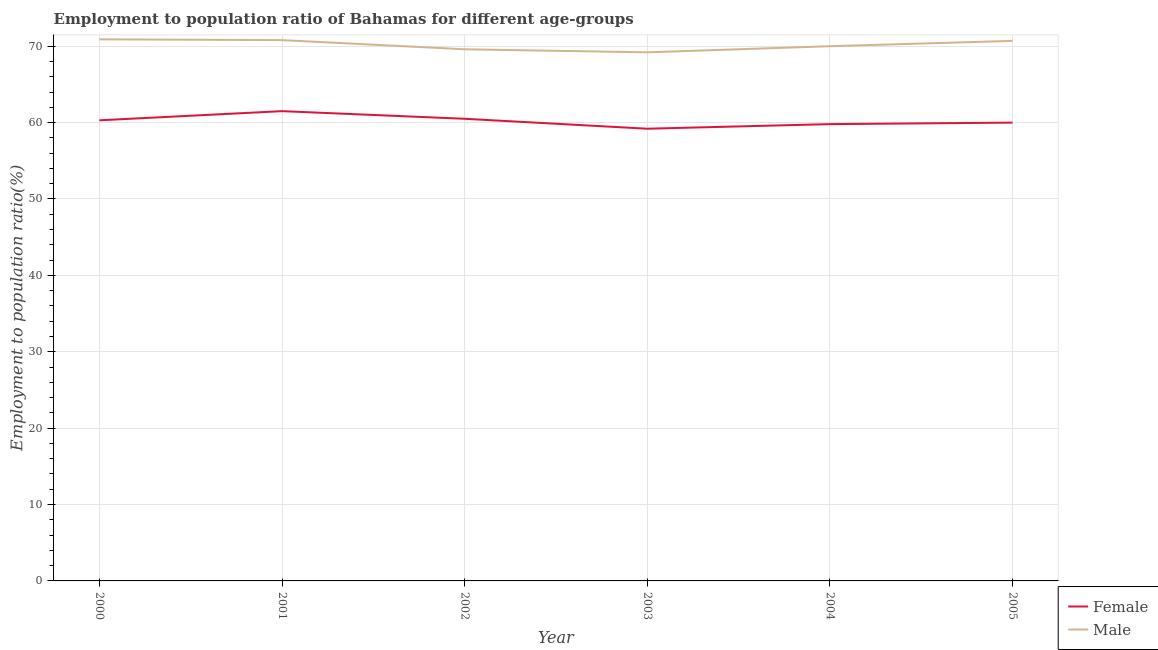How many different coloured lines are there?
Provide a short and direct response. 2. Does the line corresponding to employment to population ratio(female) intersect with the line corresponding to employment to population ratio(male)?
Offer a very short reply. No. Is the number of lines equal to the number of legend labels?
Your answer should be very brief. Yes. What is the employment to population ratio(male) in 2003?
Offer a very short reply. 69.2. Across all years, what is the maximum employment to population ratio(female)?
Give a very brief answer. 61.5. Across all years, what is the minimum employment to population ratio(female)?
Your answer should be very brief. 59.2. In which year was the employment to population ratio(female) minimum?
Your response must be concise. 2003. What is the total employment to population ratio(male) in the graph?
Ensure brevity in your answer.  421.2. What is the difference between the employment to population ratio(male) in 2000 and that in 2005?
Ensure brevity in your answer.  0.2. What is the difference between the employment to population ratio(female) in 2005 and the employment to population ratio(male) in 2002?
Provide a short and direct response. -9.6. What is the average employment to population ratio(male) per year?
Your answer should be very brief. 70.2. In the year 2002, what is the difference between the employment to population ratio(female) and employment to population ratio(male)?
Ensure brevity in your answer.  -9.1. What is the ratio of the employment to population ratio(male) in 2000 to that in 2005?
Provide a short and direct response. 1. Is the employment to population ratio(male) in 2001 less than that in 2004?
Your answer should be very brief. No. What is the difference between the highest and the second highest employment to population ratio(female)?
Your answer should be very brief. 1. What is the difference between the highest and the lowest employment to population ratio(female)?
Offer a very short reply. 2.3. Is the sum of the employment to population ratio(female) in 2003 and 2005 greater than the maximum employment to population ratio(male) across all years?
Offer a terse response. Yes. Is the employment to population ratio(male) strictly less than the employment to population ratio(female) over the years?
Offer a very short reply. No. How many lines are there?
Your response must be concise. 2. How many years are there in the graph?
Offer a very short reply. 6. What is the difference between two consecutive major ticks on the Y-axis?
Your answer should be compact. 10. Are the values on the major ticks of Y-axis written in scientific E-notation?
Provide a succinct answer. No. Where does the legend appear in the graph?
Keep it short and to the point. Bottom right. How many legend labels are there?
Your answer should be very brief. 2. What is the title of the graph?
Provide a short and direct response. Employment to population ratio of Bahamas for different age-groups. What is the label or title of the Y-axis?
Ensure brevity in your answer.  Employment to population ratio(%). What is the Employment to population ratio(%) of Female in 2000?
Keep it short and to the point. 60.3. What is the Employment to population ratio(%) of Male in 2000?
Provide a succinct answer. 70.9. What is the Employment to population ratio(%) in Female in 2001?
Ensure brevity in your answer.  61.5. What is the Employment to population ratio(%) in Male in 2001?
Your answer should be very brief. 70.8. What is the Employment to population ratio(%) in Female in 2002?
Provide a succinct answer. 60.5. What is the Employment to population ratio(%) in Male in 2002?
Offer a very short reply. 69.6. What is the Employment to population ratio(%) of Female in 2003?
Offer a very short reply. 59.2. What is the Employment to population ratio(%) in Male in 2003?
Your answer should be very brief. 69.2. What is the Employment to population ratio(%) in Female in 2004?
Keep it short and to the point. 59.8. What is the Employment to population ratio(%) of Male in 2004?
Your answer should be compact. 70. What is the Employment to population ratio(%) in Female in 2005?
Make the answer very short. 60. What is the Employment to population ratio(%) in Male in 2005?
Your answer should be compact. 70.7. Across all years, what is the maximum Employment to population ratio(%) in Female?
Offer a terse response. 61.5. Across all years, what is the maximum Employment to population ratio(%) in Male?
Your response must be concise. 70.9. Across all years, what is the minimum Employment to population ratio(%) in Female?
Make the answer very short. 59.2. Across all years, what is the minimum Employment to population ratio(%) of Male?
Your response must be concise. 69.2. What is the total Employment to population ratio(%) in Female in the graph?
Give a very brief answer. 361.3. What is the total Employment to population ratio(%) of Male in the graph?
Ensure brevity in your answer.  421.2. What is the difference between the Employment to population ratio(%) in Female in 2000 and that in 2001?
Provide a short and direct response. -1.2. What is the difference between the Employment to population ratio(%) in Female in 2000 and that in 2003?
Keep it short and to the point. 1.1. What is the difference between the Employment to population ratio(%) in Female in 2000 and that in 2004?
Provide a short and direct response. 0.5. What is the difference between the Employment to population ratio(%) in Female in 2000 and that in 2005?
Offer a terse response. 0.3. What is the difference between the Employment to population ratio(%) in Female in 2001 and that in 2005?
Offer a terse response. 1.5. What is the difference between the Employment to population ratio(%) in Male in 2002 and that in 2003?
Give a very brief answer. 0.4. What is the difference between the Employment to population ratio(%) in Female in 2002 and that in 2005?
Keep it short and to the point. 0.5. What is the difference between the Employment to population ratio(%) of Male in 2002 and that in 2005?
Give a very brief answer. -1.1. What is the difference between the Employment to population ratio(%) of Female in 2003 and that in 2004?
Your response must be concise. -0.6. What is the difference between the Employment to population ratio(%) in Female in 2003 and that in 2005?
Make the answer very short. -0.8. What is the difference between the Employment to population ratio(%) in Female in 2000 and the Employment to population ratio(%) in Male in 2002?
Ensure brevity in your answer.  -9.3. What is the difference between the Employment to population ratio(%) in Female in 2000 and the Employment to population ratio(%) in Male in 2003?
Provide a short and direct response. -8.9. What is the difference between the Employment to population ratio(%) of Female in 2001 and the Employment to population ratio(%) of Male in 2002?
Provide a succinct answer. -8.1. What is the difference between the Employment to population ratio(%) of Female in 2001 and the Employment to population ratio(%) of Male in 2004?
Offer a very short reply. -8.5. What is the difference between the Employment to population ratio(%) in Female in 2002 and the Employment to population ratio(%) in Male in 2003?
Provide a short and direct response. -8.7. What is the difference between the Employment to population ratio(%) of Female in 2003 and the Employment to population ratio(%) of Male in 2004?
Offer a terse response. -10.8. What is the average Employment to population ratio(%) of Female per year?
Give a very brief answer. 60.22. What is the average Employment to population ratio(%) in Male per year?
Provide a short and direct response. 70.2. In the year 2001, what is the difference between the Employment to population ratio(%) of Female and Employment to population ratio(%) of Male?
Offer a terse response. -9.3. In the year 2002, what is the difference between the Employment to population ratio(%) in Female and Employment to population ratio(%) in Male?
Provide a succinct answer. -9.1. In the year 2003, what is the difference between the Employment to population ratio(%) of Female and Employment to population ratio(%) of Male?
Your response must be concise. -10. In the year 2004, what is the difference between the Employment to population ratio(%) in Female and Employment to population ratio(%) in Male?
Your answer should be very brief. -10.2. In the year 2005, what is the difference between the Employment to population ratio(%) in Female and Employment to population ratio(%) in Male?
Your answer should be very brief. -10.7. What is the ratio of the Employment to population ratio(%) in Female in 2000 to that in 2001?
Provide a succinct answer. 0.98. What is the ratio of the Employment to population ratio(%) of Male in 2000 to that in 2001?
Ensure brevity in your answer.  1. What is the ratio of the Employment to population ratio(%) of Male in 2000 to that in 2002?
Your answer should be compact. 1.02. What is the ratio of the Employment to population ratio(%) in Female in 2000 to that in 2003?
Provide a short and direct response. 1.02. What is the ratio of the Employment to population ratio(%) in Male in 2000 to that in 2003?
Your response must be concise. 1.02. What is the ratio of the Employment to population ratio(%) of Female in 2000 to that in 2004?
Provide a short and direct response. 1.01. What is the ratio of the Employment to population ratio(%) of Male in 2000 to that in 2004?
Your answer should be compact. 1.01. What is the ratio of the Employment to population ratio(%) of Female in 2000 to that in 2005?
Offer a very short reply. 1. What is the ratio of the Employment to population ratio(%) in Female in 2001 to that in 2002?
Offer a terse response. 1.02. What is the ratio of the Employment to population ratio(%) of Male in 2001 to that in 2002?
Your answer should be compact. 1.02. What is the ratio of the Employment to population ratio(%) of Female in 2001 to that in 2003?
Provide a succinct answer. 1.04. What is the ratio of the Employment to population ratio(%) in Male in 2001 to that in 2003?
Offer a terse response. 1.02. What is the ratio of the Employment to population ratio(%) of Female in 2001 to that in 2004?
Make the answer very short. 1.03. What is the ratio of the Employment to population ratio(%) in Male in 2001 to that in 2004?
Offer a very short reply. 1.01. What is the ratio of the Employment to population ratio(%) in Female in 2002 to that in 2004?
Your answer should be compact. 1.01. What is the ratio of the Employment to population ratio(%) in Female in 2002 to that in 2005?
Provide a short and direct response. 1.01. What is the ratio of the Employment to population ratio(%) in Male in 2002 to that in 2005?
Make the answer very short. 0.98. What is the ratio of the Employment to population ratio(%) of Female in 2003 to that in 2004?
Make the answer very short. 0.99. What is the ratio of the Employment to population ratio(%) in Male in 2003 to that in 2004?
Give a very brief answer. 0.99. What is the ratio of the Employment to population ratio(%) in Female in 2003 to that in 2005?
Provide a short and direct response. 0.99. What is the ratio of the Employment to population ratio(%) in Male in 2003 to that in 2005?
Ensure brevity in your answer.  0.98. What is the ratio of the Employment to population ratio(%) of Female in 2004 to that in 2005?
Ensure brevity in your answer.  1. What is the ratio of the Employment to population ratio(%) in Male in 2004 to that in 2005?
Your answer should be very brief. 0.99. What is the difference between the highest and the second highest Employment to population ratio(%) in Female?
Offer a terse response. 1. 